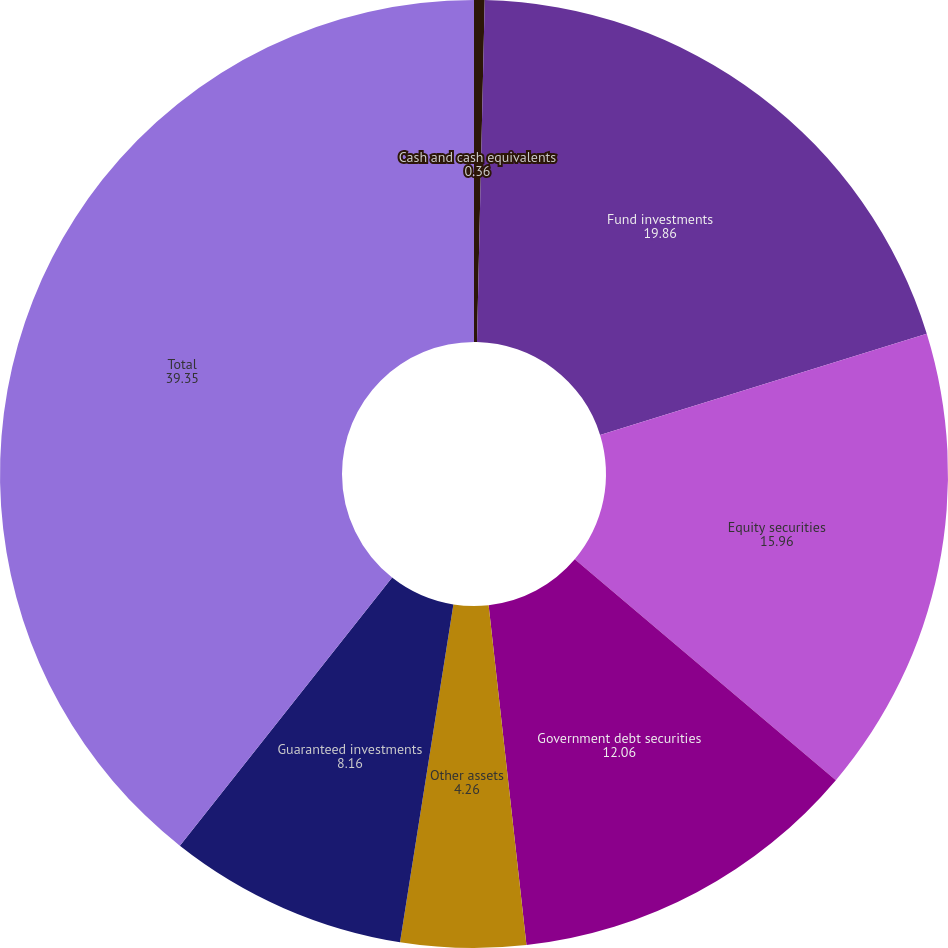<chart> <loc_0><loc_0><loc_500><loc_500><pie_chart><fcel>Cash and cash equivalents<fcel>Fund investments<fcel>Equity securities<fcel>Government debt securities<fcel>Other assets<fcel>Guaranteed investments<fcel>Total<nl><fcel>0.36%<fcel>19.86%<fcel>15.96%<fcel>12.06%<fcel>4.26%<fcel>8.16%<fcel>39.35%<nl></chart> 